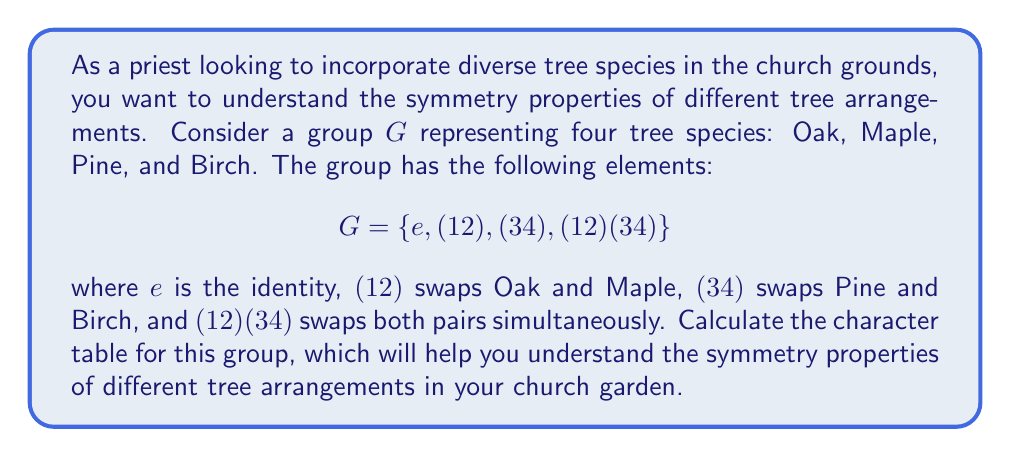Solve this math problem. To calculate the character table for the group $G$, we'll follow these steps:

1. Identify the conjugacy classes:
   - $\{e\}$
   - $\{(12), (34)\}$
   - $\{(12)(34)\}$

2. Determine the number of irreducible representations:
   The number of irreducible representations is equal to the number of conjugacy classes, which is 3.

3. Find the dimensions of the irreducible representations:
   $1^2 + 1^2 + 1^2 = 4$ (order of the group)
   So, all irreducible representations are 1-dimensional.

4. Construct the character table:

   Let $\chi_1$, $\chi_2$, and $\chi_3$ be the three irreducible characters.

   a) $\chi_1$ is the trivial representation: $\chi_1(g) = 1$ for all $g \in G$

   b) $\chi_2$ and $\chi_3$ must be orthogonal to $\chi_1$ and each other.

   c) For $\chi_2$:
      $\chi_2(e) = 1$
      $\chi_2((12)) = \chi_2((34)) = -1$ (to be orthogonal to $\chi_1$)
      $\chi_2((12)(34)) = 1$ (to satisfy $\chi_2(g)^2 = 1$)

   d) For $\chi_3$:
      $\chi_3(e) = 1$
      $\chi_3((12)) = \chi_3((34)) = 1$ (to be orthogonal to $\chi_2$)
      $\chi_3((12)(34)) = -1$ (to be orthogonal to $\chi_1$ and $\chi_2$)

5. Verify orthogonality relations:
   $\langle \chi_i, \chi_j \rangle = \frac{1}{|G|} \sum_{g \in G} \chi_i(g) \overline{\chi_j(g)} = \delta_{ij}$

The resulting character table is:

$$
\begin{array}{c|ccc}
G & \{e\} & \{(12),(34)\} & \{(12)(34)\} \\
\hline
\chi_1 & 1 & 1 & 1 \\
\chi_2 & 1 & -1 & 1 \\
\chi_3 & 1 & 1 & -1
\end{array}
$$
Answer: $$
\begin{array}{c|ccc}
G & \{e\} & \{(12),(34)\} & \{(12)(34)\} \\
\hline
\chi_1 & 1 & 1 & 1 \\
\chi_2 & 1 & -1 & 1 \\
\chi_3 & 1 & 1 & -1
\end{array}
$$ 